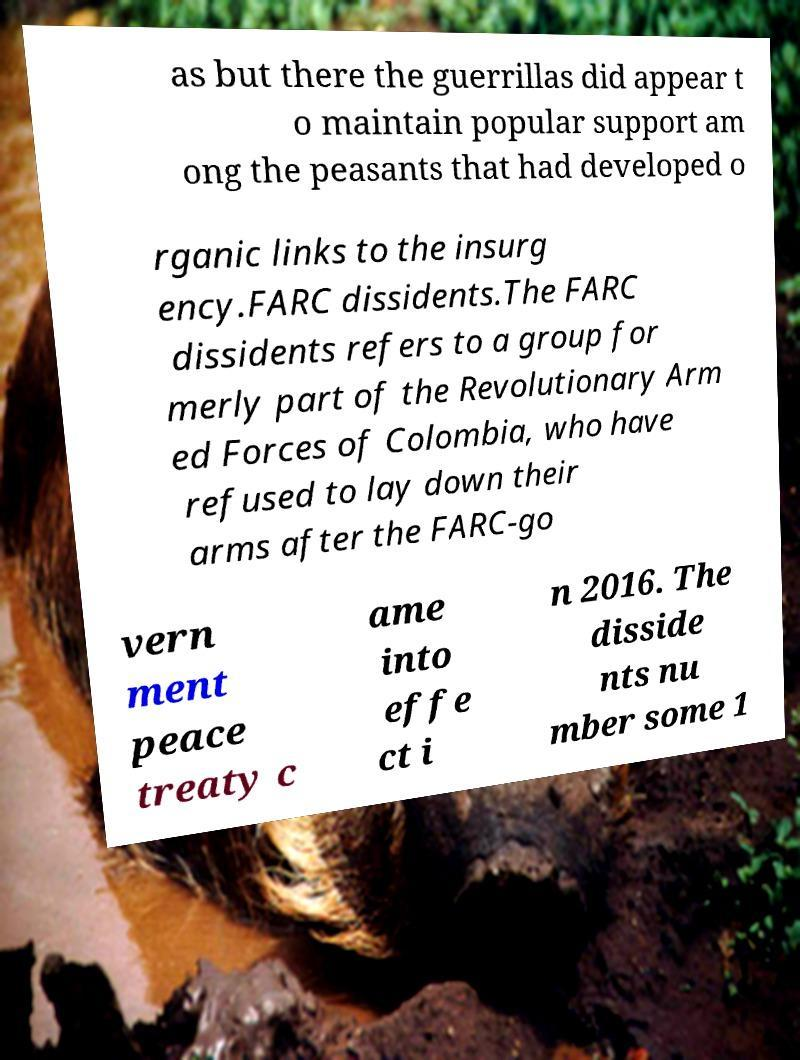Could you extract and type out the text from this image? as but there the guerrillas did appear t o maintain popular support am ong the peasants that had developed o rganic links to the insurg ency.FARC dissidents.The FARC dissidents refers to a group for merly part of the Revolutionary Arm ed Forces of Colombia, who have refused to lay down their arms after the FARC-go vern ment peace treaty c ame into effe ct i n 2016. The disside nts nu mber some 1 